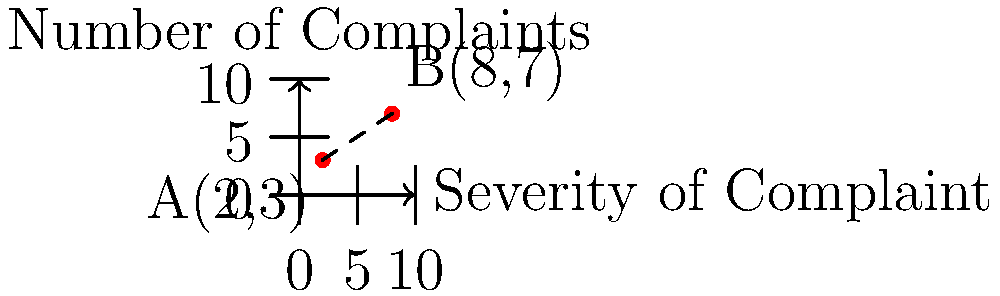In a consumer complaint analysis, two points A(2,3) and B(8,7) represent different product issues on a coordinate plane. The x-axis represents the severity of the complaint (0-10), and the y-axis represents the number of complaints (0-10). Calculate the distance between these two points to determine the relative importance of addressing these issues in a potential product recall lawsuit. To calculate the distance between two points on a coordinate plane, we use the distance formula derived from the Pythagorean theorem:

$$d = \sqrt{(x_2 - x_1)^2 + (y_2 - y_1)^2}$$

Where $(x_1, y_1)$ are the coordinates of the first point and $(x_2, y_2)$ are the coordinates of the second point.

Given:
Point A: $(x_1, y_1) = (2, 3)$
Point B: $(x_2, y_2) = (8, 7)$

Step 1: Substitute the values into the distance formula:
$$d = \sqrt{(8 - 2)^2 + (7 - 3)^2}$$

Step 2: Simplify the expressions inside the parentheses:
$$d = \sqrt{6^2 + 4^2}$$

Step 3: Calculate the squares:
$$d = \sqrt{36 + 16}$$

Step 4: Add the numbers under the square root:
$$d = \sqrt{52}$$

Step 5: Simplify the square root:
$$d = 2\sqrt{13}$$

This distance represents the relative importance of addressing these two issues in a potential product recall lawsuit. A larger distance indicates a greater difference in severity and number of complaints between the two issues.
Answer: $2\sqrt{13}$ 